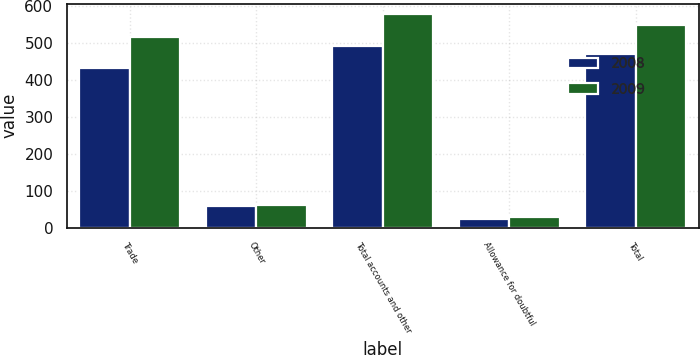Convert chart to OTSL. <chart><loc_0><loc_0><loc_500><loc_500><stacked_bar_chart><ecel><fcel>Trade<fcel>Other<fcel>Total accounts and other<fcel>Allowance for doubtful<fcel>Total<nl><fcel>2008<fcel>433.3<fcel>58.3<fcel>491.6<fcel>22.1<fcel>469.5<nl><fcel>2009<fcel>515.7<fcel>62.3<fcel>578<fcel>27.5<fcel>550.5<nl></chart> 